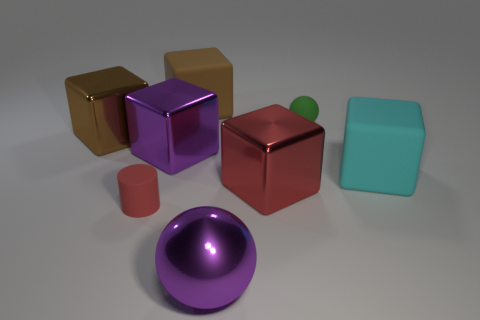How many other objects are the same size as the green rubber sphere?
Keep it short and to the point. 1. What number of objects are either big matte blocks that are on the left side of the big sphere or purple balls?
Your answer should be very brief. 2. What color is the shiny sphere?
Make the answer very short. Purple. There is a green thing behind the cyan rubber object; what is its material?
Your answer should be very brief. Rubber. Is the shape of the big brown metal object the same as the metal thing that is in front of the small rubber cylinder?
Provide a short and direct response. No. Is the number of gray cubes greater than the number of red metal objects?
Offer a very short reply. No. Is there anything else of the same color as the small rubber cylinder?
Make the answer very short. Yes. What is the shape of the tiny green thing that is made of the same material as the cylinder?
Provide a short and direct response. Sphere. There is a cube behind the metal thing to the left of the large purple metallic cube; what is its material?
Your answer should be very brief. Rubber. There is a matte thing behind the small green matte ball; is its shape the same as the red metal thing?
Make the answer very short. Yes. 